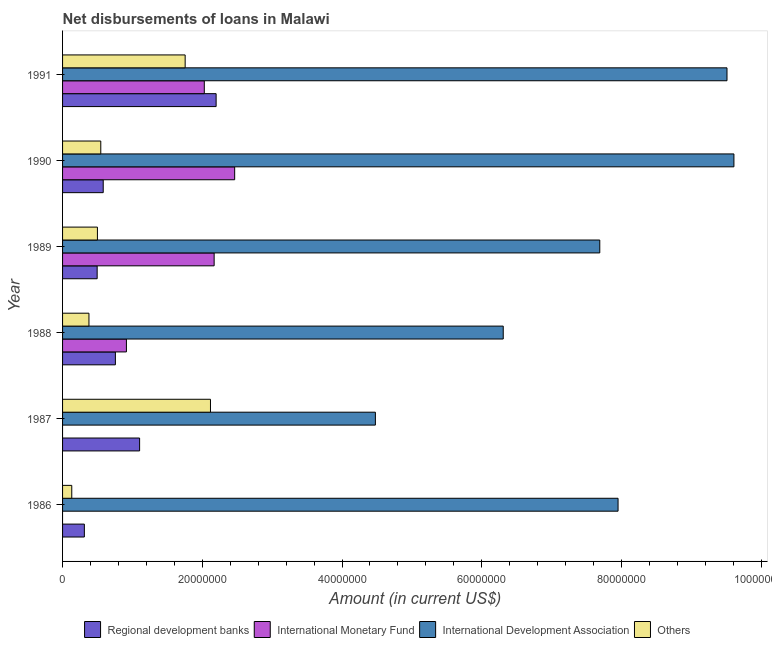How many groups of bars are there?
Ensure brevity in your answer.  6. How many bars are there on the 4th tick from the bottom?
Offer a very short reply. 4. What is the amount of loan disimbursed by other organisations in 1987?
Give a very brief answer. 2.12e+07. Across all years, what is the maximum amount of loan disimbursed by international monetary fund?
Your answer should be compact. 2.46e+07. Across all years, what is the minimum amount of loan disimbursed by regional development banks?
Provide a short and direct response. 3.12e+06. In which year was the amount of loan disimbursed by international monetary fund maximum?
Offer a very short reply. 1990. What is the total amount of loan disimbursed by international monetary fund in the graph?
Your answer should be very brief. 7.58e+07. What is the difference between the amount of loan disimbursed by international monetary fund in 1989 and that in 1991?
Offer a terse response. 1.41e+06. What is the difference between the amount of loan disimbursed by regional development banks in 1986 and the amount of loan disimbursed by international development association in 1989?
Your response must be concise. -7.38e+07. What is the average amount of loan disimbursed by international development association per year?
Give a very brief answer. 7.59e+07. In the year 1988, what is the difference between the amount of loan disimbursed by international development association and amount of loan disimbursed by international monetary fund?
Ensure brevity in your answer.  5.39e+07. What is the ratio of the amount of loan disimbursed by regional development banks in 1988 to that in 1990?
Keep it short and to the point. 1.3. Is the difference between the amount of loan disimbursed by other organisations in 1988 and 1991 greater than the difference between the amount of loan disimbursed by international monetary fund in 1988 and 1991?
Your answer should be compact. No. What is the difference between the highest and the second highest amount of loan disimbursed by regional development banks?
Ensure brevity in your answer.  1.10e+07. What is the difference between the highest and the lowest amount of loan disimbursed by other organisations?
Provide a short and direct response. 1.99e+07. In how many years, is the amount of loan disimbursed by regional development banks greater than the average amount of loan disimbursed by regional development banks taken over all years?
Ensure brevity in your answer.  2. Is the sum of the amount of loan disimbursed by other organisations in 1986 and 1991 greater than the maximum amount of loan disimbursed by international monetary fund across all years?
Offer a terse response. No. Is it the case that in every year, the sum of the amount of loan disimbursed by international development association and amount of loan disimbursed by regional development banks is greater than the sum of amount of loan disimbursed by international monetary fund and amount of loan disimbursed by other organisations?
Your answer should be very brief. Yes. Are all the bars in the graph horizontal?
Provide a succinct answer. Yes. What is the difference between two consecutive major ticks on the X-axis?
Provide a succinct answer. 2.00e+07. Are the values on the major ticks of X-axis written in scientific E-notation?
Keep it short and to the point. No. Does the graph contain grids?
Your response must be concise. No. How are the legend labels stacked?
Give a very brief answer. Horizontal. What is the title of the graph?
Keep it short and to the point. Net disbursements of loans in Malawi. What is the label or title of the X-axis?
Provide a short and direct response. Amount (in current US$). What is the Amount (in current US$) of Regional development banks in 1986?
Make the answer very short. 3.12e+06. What is the Amount (in current US$) of International Monetary Fund in 1986?
Your response must be concise. 0. What is the Amount (in current US$) in International Development Association in 1986?
Keep it short and to the point. 7.95e+07. What is the Amount (in current US$) of Others in 1986?
Your answer should be very brief. 1.32e+06. What is the Amount (in current US$) of Regional development banks in 1987?
Make the answer very short. 1.10e+07. What is the Amount (in current US$) in International Development Association in 1987?
Give a very brief answer. 4.48e+07. What is the Amount (in current US$) in Others in 1987?
Your answer should be very brief. 2.12e+07. What is the Amount (in current US$) in Regional development banks in 1988?
Keep it short and to the point. 7.56e+06. What is the Amount (in current US$) in International Monetary Fund in 1988?
Offer a very short reply. 9.14e+06. What is the Amount (in current US$) in International Development Association in 1988?
Your response must be concise. 6.31e+07. What is the Amount (in current US$) in Others in 1988?
Provide a succinct answer. 3.78e+06. What is the Amount (in current US$) in Regional development banks in 1989?
Give a very brief answer. 4.95e+06. What is the Amount (in current US$) of International Monetary Fund in 1989?
Keep it short and to the point. 2.17e+07. What is the Amount (in current US$) of International Development Association in 1989?
Provide a succinct answer. 7.69e+07. What is the Amount (in current US$) of Others in 1989?
Your response must be concise. 4.99e+06. What is the Amount (in current US$) of Regional development banks in 1990?
Provide a short and direct response. 5.82e+06. What is the Amount (in current US$) in International Monetary Fund in 1990?
Give a very brief answer. 2.46e+07. What is the Amount (in current US$) of International Development Association in 1990?
Your answer should be very brief. 9.61e+07. What is the Amount (in current US$) of Others in 1990?
Ensure brevity in your answer.  5.47e+06. What is the Amount (in current US$) in Regional development banks in 1991?
Provide a short and direct response. 2.20e+07. What is the Amount (in current US$) of International Monetary Fund in 1991?
Provide a succinct answer. 2.03e+07. What is the Amount (in current US$) in International Development Association in 1991?
Your answer should be compact. 9.51e+07. What is the Amount (in current US$) of Others in 1991?
Offer a very short reply. 1.75e+07. Across all years, what is the maximum Amount (in current US$) of Regional development banks?
Offer a very short reply. 2.20e+07. Across all years, what is the maximum Amount (in current US$) in International Monetary Fund?
Keep it short and to the point. 2.46e+07. Across all years, what is the maximum Amount (in current US$) of International Development Association?
Your answer should be compact. 9.61e+07. Across all years, what is the maximum Amount (in current US$) in Others?
Ensure brevity in your answer.  2.12e+07. Across all years, what is the minimum Amount (in current US$) of Regional development banks?
Your answer should be very brief. 3.12e+06. Across all years, what is the minimum Amount (in current US$) in International Monetary Fund?
Your response must be concise. 0. Across all years, what is the minimum Amount (in current US$) of International Development Association?
Your answer should be very brief. 4.48e+07. Across all years, what is the minimum Amount (in current US$) in Others?
Offer a very short reply. 1.32e+06. What is the total Amount (in current US$) of Regional development banks in the graph?
Ensure brevity in your answer.  5.45e+07. What is the total Amount (in current US$) of International Monetary Fund in the graph?
Ensure brevity in your answer.  7.58e+07. What is the total Amount (in current US$) in International Development Association in the graph?
Your answer should be compact. 4.55e+08. What is the total Amount (in current US$) in Others in the graph?
Your answer should be compact. 5.43e+07. What is the difference between the Amount (in current US$) of Regional development banks in 1986 and that in 1987?
Provide a short and direct response. -7.91e+06. What is the difference between the Amount (in current US$) in International Development Association in 1986 and that in 1987?
Offer a terse response. 3.47e+07. What is the difference between the Amount (in current US$) in Others in 1986 and that in 1987?
Make the answer very short. -1.99e+07. What is the difference between the Amount (in current US$) of Regional development banks in 1986 and that in 1988?
Provide a short and direct response. -4.44e+06. What is the difference between the Amount (in current US$) of International Development Association in 1986 and that in 1988?
Give a very brief answer. 1.64e+07. What is the difference between the Amount (in current US$) of Others in 1986 and that in 1988?
Offer a very short reply. -2.46e+06. What is the difference between the Amount (in current US$) of Regional development banks in 1986 and that in 1989?
Ensure brevity in your answer.  -1.83e+06. What is the difference between the Amount (in current US$) in International Development Association in 1986 and that in 1989?
Provide a succinct answer. 2.62e+06. What is the difference between the Amount (in current US$) of Others in 1986 and that in 1989?
Your answer should be compact. -3.67e+06. What is the difference between the Amount (in current US$) of Regional development banks in 1986 and that in 1990?
Provide a succinct answer. -2.70e+06. What is the difference between the Amount (in current US$) in International Development Association in 1986 and that in 1990?
Your answer should be compact. -1.66e+07. What is the difference between the Amount (in current US$) in Others in 1986 and that in 1990?
Your response must be concise. -4.15e+06. What is the difference between the Amount (in current US$) in Regional development banks in 1986 and that in 1991?
Give a very brief answer. -1.89e+07. What is the difference between the Amount (in current US$) in International Development Association in 1986 and that in 1991?
Make the answer very short. -1.56e+07. What is the difference between the Amount (in current US$) of Others in 1986 and that in 1991?
Offer a very short reply. -1.62e+07. What is the difference between the Amount (in current US$) in Regional development banks in 1987 and that in 1988?
Offer a very short reply. 3.47e+06. What is the difference between the Amount (in current US$) in International Development Association in 1987 and that in 1988?
Provide a short and direct response. -1.83e+07. What is the difference between the Amount (in current US$) of Others in 1987 and that in 1988?
Provide a succinct answer. 1.74e+07. What is the difference between the Amount (in current US$) of Regional development banks in 1987 and that in 1989?
Provide a short and direct response. 6.08e+06. What is the difference between the Amount (in current US$) in International Development Association in 1987 and that in 1989?
Give a very brief answer. -3.21e+07. What is the difference between the Amount (in current US$) in Others in 1987 and that in 1989?
Keep it short and to the point. 1.62e+07. What is the difference between the Amount (in current US$) of Regional development banks in 1987 and that in 1990?
Provide a succinct answer. 5.21e+06. What is the difference between the Amount (in current US$) in International Development Association in 1987 and that in 1990?
Make the answer very short. -5.13e+07. What is the difference between the Amount (in current US$) of Others in 1987 and that in 1990?
Offer a very short reply. 1.57e+07. What is the difference between the Amount (in current US$) of Regional development banks in 1987 and that in 1991?
Ensure brevity in your answer.  -1.10e+07. What is the difference between the Amount (in current US$) in International Development Association in 1987 and that in 1991?
Make the answer very short. -5.03e+07. What is the difference between the Amount (in current US$) of Others in 1987 and that in 1991?
Make the answer very short. 3.62e+06. What is the difference between the Amount (in current US$) of Regional development banks in 1988 and that in 1989?
Provide a succinct answer. 2.61e+06. What is the difference between the Amount (in current US$) of International Monetary Fund in 1988 and that in 1989?
Provide a succinct answer. -1.26e+07. What is the difference between the Amount (in current US$) of International Development Association in 1988 and that in 1989?
Make the answer very short. -1.38e+07. What is the difference between the Amount (in current US$) of Others in 1988 and that in 1989?
Offer a very short reply. -1.21e+06. What is the difference between the Amount (in current US$) of Regional development banks in 1988 and that in 1990?
Your response must be concise. 1.74e+06. What is the difference between the Amount (in current US$) in International Monetary Fund in 1988 and that in 1990?
Offer a very short reply. -1.55e+07. What is the difference between the Amount (in current US$) in International Development Association in 1988 and that in 1990?
Offer a very short reply. -3.30e+07. What is the difference between the Amount (in current US$) in Others in 1988 and that in 1990?
Ensure brevity in your answer.  -1.69e+06. What is the difference between the Amount (in current US$) of Regional development banks in 1988 and that in 1991?
Keep it short and to the point. -1.44e+07. What is the difference between the Amount (in current US$) of International Monetary Fund in 1988 and that in 1991?
Offer a terse response. -1.11e+07. What is the difference between the Amount (in current US$) of International Development Association in 1988 and that in 1991?
Offer a terse response. -3.20e+07. What is the difference between the Amount (in current US$) of Others in 1988 and that in 1991?
Provide a short and direct response. -1.38e+07. What is the difference between the Amount (in current US$) of Regional development banks in 1989 and that in 1990?
Provide a short and direct response. -8.68e+05. What is the difference between the Amount (in current US$) of International Monetary Fund in 1989 and that in 1990?
Keep it short and to the point. -2.94e+06. What is the difference between the Amount (in current US$) in International Development Association in 1989 and that in 1990?
Ensure brevity in your answer.  -1.92e+07. What is the difference between the Amount (in current US$) of Others in 1989 and that in 1990?
Your response must be concise. -4.80e+05. What is the difference between the Amount (in current US$) of Regional development banks in 1989 and that in 1991?
Provide a short and direct response. -1.70e+07. What is the difference between the Amount (in current US$) in International Monetary Fund in 1989 and that in 1991?
Make the answer very short. 1.41e+06. What is the difference between the Amount (in current US$) in International Development Association in 1989 and that in 1991?
Ensure brevity in your answer.  -1.82e+07. What is the difference between the Amount (in current US$) of Others in 1989 and that in 1991?
Offer a terse response. -1.26e+07. What is the difference between the Amount (in current US$) in Regional development banks in 1990 and that in 1991?
Make the answer very short. -1.62e+07. What is the difference between the Amount (in current US$) of International Monetary Fund in 1990 and that in 1991?
Your response must be concise. 4.35e+06. What is the difference between the Amount (in current US$) of International Development Association in 1990 and that in 1991?
Ensure brevity in your answer.  9.91e+05. What is the difference between the Amount (in current US$) of Others in 1990 and that in 1991?
Your answer should be compact. -1.21e+07. What is the difference between the Amount (in current US$) of Regional development banks in 1986 and the Amount (in current US$) of International Development Association in 1987?
Provide a short and direct response. -4.17e+07. What is the difference between the Amount (in current US$) of Regional development banks in 1986 and the Amount (in current US$) of Others in 1987?
Offer a terse response. -1.80e+07. What is the difference between the Amount (in current US$) of International Development Association in 1986 and the Amount (in current US$) of Others in 1987?
Your response must be concise. 5.83e+07. What is the difference between the Amount (in current US$) of Regional development banks in 1986 and the Amount (in current US$) of International Monetary Fund in 1988?
Ensure brevity in your answer.  -6.02e+06. What is the difference between the Amount (in current US$) of Regional development banks in 1986 and the Amount (in current US$) of International Development Association in 1988?
Keep it short and to the point. -6.00e+07. What is the difference between the Amount (in current US$) in Regional development banks in 1986 and the Amount (in current US$) in Others in 1988?
Provide a short and direct response. -6.57e+05. What is the difference between the Amount (in current US$) of International Development Association in 1986 and the Amount (in current US$) of Others in 1988?
Offer a terse response. 7.57e+07. What is the difference between the Amount (in current US$) of Regional development banks in 1986 and the Amount (in current US$) of International Monetary Fund in 1989?
Offer a very short reply. -1.86e+07. What is the difference between the Amount (in current US$) of Regional development banks in 1986 and the Amount (in current US$) of International Development Association in 1989?
Make the answer very short. -7.38e+07. What is the difference between the Amount (in current US$) in Regional development banks in 1986 and the Amount (in current US$) in Others in 1989?
Provide a short and direct response. -1.87e+06. What is the difference between the Amount (in current US$) of International Development Association in 1986 and the Amount (in current US$) of Others in 1989?
Your answer should be compact. 7.45e+07. What is the difference between the Amount (in current US$) in Regional development banks in 1986 and the Amount (in current US$) in International Monetary Fund in 1990?
Your answer should be compact. -2.15e+07. What is the difference between the Amount (in current US$) of Regional development banks in 1986 and the Amount (in current US$) of International Development Association in 1990?
Your response must be concise. -9.30e+07. What is the difference between the Amount (in current US$) in Regional development banks in 1986 and the Amount (in current US$) in Others in 1990?
Ensure brevity in your answer.  -2.35e+06. What is the difference between the Amount (in current US$) in International Development Association in 1986 and the Amount (in current US$) in Others in 1990?
Your answer should be compact. 7.40e+07. What is the difference between the Amount (in current US$) of Regional development banks in 1986 and the Amount (in current US$) of International Monetary Fund in 1991?
Give a very brief answer. -1.72e+07. What is the difference between the Amount (in current US$) of Regional development banks in 1986 and the Amount (in current US$) of International Development Association in 1991?
Offer a very short reply. -9.20e+07. What is the difference between the Amount (in current US$) in Regional development banks in 1986 and the Amount (in current US$) in Others in 1991?
Offer a terse response. -1.44e+07. What is the difference between the Amount (in current US$) of International Development Association in 1986 and the Amount (in current US$) of Others in 1991?
Offer a terse response. 6.20e+07. What is the difference between the Amount (in current US$) in Regional development banks in 1987 and the Amount (in current US$) in International Monetary Fund in 1988?
Your response must be concise. 1.89e+06. What is the difference between the Amount (in current US$) of Regional development banks in 1987 and the Amount (in current US$) of International Development Association in 1988?
Your answer should be very brief. -5.20e+07. What is the difference between the Amount (in current US$) in Regional development banks in 1987 and the Amount (in current US$) in Others in 1988?
Keep it short and to the point. 7.25e+06. What is the difference between the Amount (in current US$) of International Development Association in 1987 and the Amount (in current US$) of Others in 1988?
Your response must be concise. 4.10e+07. What is the difference between the Amount (in current US$) in Regional development banks in 1987 and the Amount (in current US$) in International Monetary Fund in 1989?
Your answer should be compact. -1.07e+07. What is the difference between the Amount (in current US$) in Regional development banks in 1987 and the Amount (in current US$) in International Development Association in 1989?
Your answer should be very brief. -6.59e+07. What is the difference between the Amount (in current US$) in Regional development banks in 1987 and the Amount (in current US$) in Others in 1989?
Give a very brief answer. 6.04e+06. What is the difference between the Amount (in current US$) of International Development Association in 1987 and the Amount (in current US$) of Others in 1989?
Make the answer very short. 3.98e+07. What is the difference between the Amount (in current US$) of Regional development banks in 1987 and the Amount (in current US$) of International Monetary Fund in 1990?
Offer a terse response. -1.36e+07. What is the difference between the Amount (in current US$) in Regional development banks in 1987 and the Amount (in current US$) in International Development Association in 1990?
Provide a short and direct response. -8.51e+07. What is the difference between the Amount (in current US$) of Regional development banks in 1987 and the Amount (in current US$) of Others in 1990?
Offer a terse response. 5.56e+06. What is the difference between the Amount (in current US$) in International Development Association in 1987 and the Amount (in current US$) in Others in 1990?
Your answer should be compact. 3.93e+07. What is the difference between the Amount (in current US$) in Regional development banks in 1987 and the Amount (in current US$) in International Monetary Fund in 1991?
Make the answer very short. -9.26e+06. What is the difference between the Amount (in current US$) of Regional development banks in 1987 and the Amount (in current US$) of International Development Association in 1991?
Your answer should be compact. -8.41e+07. What is the difference between the Amount (in current US$) of Regional development banks in 1987 and the Amount (in current US$) of Others in 1991?
Provide a succinct answer. -6.52e+06. What is the difference between the Amount (in current US$) of International Development Association in 1987 and the Amount (in current US$) of Others in 1991?
Provide a succinct answer. 2.72e+07. What is the difference between the Amount (in current US$) in Regional development banks in 1988 and the Amount (in current US$) in International Monetary Fund in 1989?
Your answer should be very brief. -1.41e+07. What is the difference between the Amount (in current US$) in Regional development banks in 1988 and the Amount (in current US$) in International Development Association in 1989?
Ensure brevity in your answer.  -6.93e+07. What is the difference between the Amount (in current US$) in Regional development banks in 1988 and the Amount (in current US$) in Others in 1989?
Make the answer very short. 2.57e+06. What is the difference between the Amount (in current US$) of International Monetary Fund in 1988 and the Amount (in current US$) of International Development Association in 1989?
Your answer should be very brief. -6.78e+07. What is the difference between the Amount (in current US$) of International Monetary Fund in 1988 and the Amount (in current US$) of Others in 1989?
Your answer should be very brief. 4.15e+06. What is the difference between the Amount (in current US$) in International Development Association in 1988 and the Amount (in current US$) in Others in 1989?
Ensure brevity in your answer.  5.81e+07. What is the difference between the Amount (in current US$) of Regional development banks in 1988 and the Amount (in current US$) of International Monetary Fund in 1990?
Ensure brevity in your answer.  -1.71e+07. What is the difference between the Amount (in current US$) of Regional development banks in 1988 and the Amount (in current US$) of International Development Association in 1990?
Give a very brief answer. -8.85e+07. What is the difference between the Amount (in current US$) in Regional development banks in 1988 and the Amount (in current US$) in Others in 1990?
Offer a terse response. 2.09e+06. What is the difference between the Amount (in current US$) of International Monetary Fund in 1988 and the Amount (in current US$) of International Development Association in 1990?
Your answer should be compact. -8.70e+07. What is the difference between the Amount (in current US$) in International Monetary Fund in 1988 and the Amount (in current US$) in Others in 1990?
Offer a very short reply. 3.67e+06. What is the difference between the Amount (in current US$) of International Development Association in 1988 and the Amount (in current US$) of Others in 1990?
Keep it short and to the point. 5.76e+07. What is the difference between the Amount (in current US$) of Regional development banks in 1988 and the Amount (in current US$) of International Monetary Fund in 1991?
Make the answer very short. -1.27e+07. What is the difference between the Amount (in current US$) of Regional development banks in 1988 and the Amount (in current US$) of International Development Association in 1991?
Keep it short and to the point. -8.75e+07. What is the difference between the Amount (in current US$) in Regional development banks in 1988 and the Amount (in current US$) in Others in 1991?
Make the answer very short. -9.99e+06. What is the difference between the Amount (in current US$) of International Monetary Fund in 1988 and the Amount (in current US$) of International Development Association in 1991?
Offer a terse response. -8.60e+07. What is the difference between the Amount (in current US$) of International Monetary Fund in 1988 and the Amount (in current US$) of Others in 1991?
Make the answer very short. -8.41e+06. What is the difference between the Amount (in current US$) in International Development Association in 1988 and the Amount (in current US$) in Others in 1991?
Give a very brief answer. 4.55e+07. What is the difference between the Amount (in current US$) in Regional development banks in 1989 and the Amount (in current US$) in International Monetary Fund in 1990?
Your response must be concise. -1.97e+07. What is the difference between the Amount (in current US$) of Regional development banks in 1989 and the Amount (in current US$) of International Development Association in 1990?
Give a very brief answer. -9.11e+07. What is the difference between the Amount (in current US$) in Regional development banks in 1989 and the Amount (in current US$) in Others in 1990?
Your answer should be very brief. -5.20e+05. What is the difference between the Amount (in current US$) in International Monetary Fund in 1989 and the Amount (in current US$) in International Development Association in 1990?
Offer a terse response. -7.44e+07. What is the difference between the Amount (in current US$) in International Monetary Fund in 1989 and the Amount (in current US$) in Others in 1990?
Provide a succinct answer. 1.62e+07. What is the difference between the Amount (in current US$) in International Development Association in 1989 and the Amount (in current US$) in Others in 1990?
Your response must be concise. 7.14e+07. What is the difference between the Amount (in current US$) of Regional development banks in 1989 and the Amount (in current US$) of International Monetary Fund in 1991?
Make the answer very short. -1.53e+07. What is the difference between the Amount (in current US$) in Regional development banks in 1989 and the Amount (in current US$) in International Development Association in 1991?
Offer a terse response. -9.02e+07. What is the difference between the Amount (in current US$) of Regional development banks in 1989 and the Amount (in current US$) of Others in 1991?
Provide a short and direct response. -1.26e+07. What is the difference between the Amount (in current US$) of International Monetary Fund in 1989 and the Amount (in current US$) of International Development Association in 1991?
Keep it short and to the point. -7.34e+07. What is the difference between the Amount (in current US$) of International Monetary Fund in 1989 and the Amount (in current US$) of Others in 1991?
Make the answer very short. 4.15e+06. What is the difference between the Amount (in current US$) of International Development Association in 1989 and the Amount (in current US$) of Others in 1991?
Your answer should be compact. 5.93e+07. What is the difference between the Amount (in current US$) of Regional development banks in 1990 and the Amount (in current US$) of International Monetary Fund in 1991?
Provide a succinct answer. -1.45e+07. What is the difference between the Amount (in current US$) of Regional development banks in 1990 and the Amount (in current US$) of International Development Association in 1991?
Offer a terse response. -8.93e+07. What is the difference between the Amount (in current US$) in Regional development banks in 1990 and the Amount (in current US$) in Others in 1991?
Ensure brevity in your answer.  -1.17e+07. What is the difference between the Amount (in current US$) in International Monetary Fund in 1990 and the Amount (in current US$) in International Development Association in 1991?
Provide a succinct answer. -7.05e+07. What is the difference between the Amount (in current US$) in International Monetary Fund in 1990 and the Amount (in current US$) in Others in 1991?
Your answer should be very brief. 7.09e+06. What is the difference between the Amount (in current US$) of International Development Association in 1990 and the Amount (in current US$) of Others in 1991?
Give a very brief answer. 7.85e+07. What is the average Amount (in current US$) in Regional development banks per year?
Offer a very short reply. 9.08e+06. What is the average Amount (in current US$) in International Monetary Fund per year?
Your answer should be very brief. 1.26e+07. What is the average Amount (in current US$) of International Development Association per year?
Your answer should be compact. 7.59e+07. What is the average Amount (in current US$) of Others per year?
Make the answer very short. 9.04e+06. In the year 1986, what is the difference between the Amount (in current US$) in Regional development banks and Amount (in current US$) in International Development Association?
Provide a succinct answer. -7.64e+07. In the year 1986, what is the difference between the Amount (in current US$) of Regional development banks and Amount (in current US$) of Others?
Your response must be concise. 1.80e+06. In the year 1986, what is the difference between the Amount (in current US$) of International Development Association and Amount (in current US$) of Others?
Provide a short and direct response. 7.82e+07. In the year 1987, what is the difference between the Amount (in current US$) of Regional development banks and Amount (in current US$) of International Development Association?
Your answer should be very brief. -3.37e+07. In the year 1987, what is the difference between the Amount (in current US$) in Regional development banks and Amount (in current US$) in Others?
Ensure brevity in your answer.  -1.01e+07. In the year 1987, what is the difference between the Amount (in current US$) of International Development Association and Amount (in current US$) of Others?
Ensure brevity in your answer.  2.36e+07. In the year 1988, what is the difference between the Amount (in current US$) of Regional development banks and Amount (in current US$) of International Monetary Fund?
Provide a short and direct response. -1.58e+06. In the year 1988, what is the difference between the Amount (in current US$) of Regional development banks and Amount (in current US$) of International Development Association?
Provide a succinct answer. -5.55e+07. In the year 1988, what is the difference between the Amount (in current US$) in Regional development banks and Amount (in current US$) in Others?
Your response must be concise. 3.78e+06. In the year 1988, what is the difference between the Amount (in current US$) in International Monetary Fund and Amount (in current US$) in International Development Association?
Keep it short and to the point. -5.39e+07. In the year 1988, what is the difference between the Amount (in current US$) in International Monetary Fund and Amount (in current US$) in Others?
Offer a terse response. 5.36e+06. In the year 1988, what is the difference between the Amount (in current US$) of International Development Association and Amount (in current US$) of Others?
Your answer should be compact. 5.93e+07. In the year 1989, what is the difference between the Amount (in current US$) in Regional development banks and Amount (in current US$) in International Monetary Fund?
Your response must be concise. -1.67e+07. In the year 1989, what is the difference between the Amount (in current US$) in Regional development banks and Amount (in current US$) in International Development Association?
Provide a short and direct response. -7.19e+07. In the year 1989, what is the difference between the Amount (in current US$) of International Monetary Fund and Amount (in current US$) of International Development Association?
Provide a succinct answer. -5.52e+07. In the year 1989, what is the difference between the Amount (in current US$) of International Monetary Fund and Amount (in current US$) of Others?
Give a very brief answer. 1.67e+07. In the year 1989, what is the difference between the Amount (in current US$) in International Development Association and Amount (in current US$) in Others?
Give a very brief answer. 7.19e+07. In the year 1990, what is the difference between the Amount (in current US$) of Regional development banks and Amount (in current US$) of International Monetary Fund?
Make the answer very short. -1.88e+07. In the year 1990, what is the difference between the Amount (in current US$) of Regional development banks and Amount (in current US$) of International Development Association?
Keep it short and to the point. -9.03e+07. In the year 1990, what is the difference between the Amount (in current US$) in Regional development banks and Amount (in current US$) in Others?
Your answer should be very brief. 3.48e+05. In the year 1990, what is the difference between the Amount (in current US$) of International Monetary Fund and Amount (in current US$) of International Development Association?
Keep it short and to the point. -7.15e+07. In the year 1990, what is the difference between the Amount (in current US$) in International Monetary Fund and Amount (in current US$) in Others?
Your answer should be compact. 1.92e+07. In the year 1990, what is the difference between the Amount (in current US$) of International Development Association and Amount (in current US$) of Others?
Provide a short and direct response. 9.06e+07. In the year 1991, what is the difference between the Amount (in current US$) of Regional development banks and Amount (in current US$) of International Monetary Fund?
Make the answer very short. 1.69e+06. In the year 1991, what is the difference between the Amount (in current US$) in Regional development banks and Amount (in current US$) in International Development Association?
Ensure brevity in your answer.  -7.31e+07. In the year 1991, what is the difference between the Amount (in current US$) of Regional development banks and Amount (in current US$) of Others?
Offer a very short reply. 4.43e+06. In the year 1991, what is the difference between the Amount (in current US$) in International Monetary Fund and Amount (in current US$) in International Development Association?
Your answer should be compact. -7.48e+07. In the year 1991, what is the difference between the Amount (in current US$) of International Monetary Fund and Amount (in current US$) of Others?
Give a very brief answer. 2.74e+06. In the year 1991, what is the difference between the Amount (in current US$) in International Development Association and Amount (in current US$) in Others?
Offer a terse response. 7.76e+07. What is the ratio of the Amount (in current US$) in Regional development banks in 1986 to that in 1987?
Keep it short and to the point. 0.28. What is the ratio of the Amount (in current US$) of International Development Association in 1986 to that in 1987?
Your answer should be very brief. 1.78. What is the ratio of the Amount (in current US$) of Others in 1986 to that in 1987?
Provide a short and direct response. 0.06. What is the ratio of the Amount (in current US$) in Regional development banks in 1986 to that in 1988?
Make the answer very short. 0.41. What is the ratio of the Amount (in current US$) in International Development Association in 1986 to that in 1988?
Offer a terse response. 1.26. What is the ratio of the Amount (in current US$) of Others in 1986 to that in 1988?
Ensure brevity in your answer.  0.35. What is the ratio of the Amount (in current US$) of Regional development banks in 1986 to that in 1989?
Provide a short and direct response. 0.63. What is the ratio of the Amount (in current US$) in International Development Association in 1986 to that in 1989?
Your answer should be compact. 1.03. What is the ratio of the Amount (in current US$) in Others in 1986 to that in 1989?
Ensure brevity in your answer.  0.26. What is the ratio of the Amount (in current US$) of Regional development banks in 1986 to that in 1990?
Offer a very short reply. 0.54. What is the ratio of the Amount (in current US$) in International Development Association in 1986 to that in 1990?
Your answer should be compact. 0.83. What is the ratio of the Amount (in current US$) in Others in 1986 to that in 1990?
Your response must be concise. 0.24. What is the ratio of the Amount (in current US$) of Regional development banks in 1986 to that in 1991?
Your response must be concise. 0.14. What is the ratio of the Amount (in current US$) in International Development Association in 1986 to that in 1991?
Your answer should be compact. 0.84. What is the ratio of the Amount (in current US$) in Others in 1986 to that in 1991?
Ensure brevity in your answer.  0.07. What is the ratio of the Amount (in current US$) of Regional development banks in 1987 to that in 1988?
Offer a very short reply. 1.46. What is the ratio of the Amount (in current US$) in International Development Association in 1987 to that in 1988?
Your response must be concise. 0.71. What is the ratio of the Amount (in current US$) of Others in 1987 to that in 1988?
Your response must be concise. 5.61. What is the ratio of the Amount (in current US$) of Regional development banks in 1987 to that in 1989?
Your response must be concise. 2.23. What is the ratio of the Amount (in current US$) in International Development Association in 1987 to that in 1989?
Your answer should be compact. 0.58. What is the ratio of the Amount (in current US$) in Others in 1987 to that in 1989?
Your answer should be compact. 4.24. What is the ratio of the Amount (in current US$) of Regional development banks in 1987 to that in 1990?
Give a very brief answer. 1.9. What is the ratio of the Amount (in current US$) in International Development Association in 1987 to that in 1990?
Your answer should be compact. 0.47. What is the ratio of the Amount (in current US$) in Others in 1987 to that in 1990?
Your response must be concise. 3.87. What is the ratio of the Amount (in current US$) of Regional development banks in 1987 to that in 1991?
Offer a very short reply. 0.5. What is the ratio of the Amount (in current US$) in International Development Association in 1987 to that in 1991?
Offer a terse response. 0.47. What is the ratio of the Amount (in current US$) in Others in 1987 to that in 1991?
Your answer should be compact. 1.21. What is the ratio of the Amount (in current US$) of Regional development banks in 1988 to that in 1989?
Your response must be concise. 1.53. What is the ratio of the Amount (in current US$) in International Monetary Fund in 1988 to that in 1989?
Offer a very short reply. 0.42. What is the ratio of the Amount (in current US$) of International Development Association in 1988 to that in 1989?
Ensure brevity in your answer.  0.82. What is the ratio of the Amount (in current US$) in Others in 1988 to that in 1989?
Give a very brief answer. 0.76. What is the ratio of the Amount (in current US$) in Regional development banks in 1988 to that in 1990?
Offer a very short reply. 1.3. What is the ratio of the Amount (in current US$) of International Monetary Fund in 1988 to that in 1990?
Ensure brevity in your answer.  0.37. What is the ratio of the Amount (in current US$) in International Development Association in 1988 to that in 1990?
Your answer should be compact. 0.66. What is the ratio of the Amount (in current US$) of Others in 1988 to that in 1990?
Your response must be concise. 0.69. What is the ratio of the Amount (in current US$) in Regional development banks in 1988 to that in 1991?
Your answer should be very brief. 0.34. What is the ratio of the Amount (in current US$) in International Monetary Fund in 1988 to that in 1991?
Provide a succinct answer. 0.45. What is the ratio of the Amount (in current US$) in International Development Association in 1988 to that in 1991?
Provide a short and direct response. 0.66. What is the ratio of the Amount (in current US$) in Others in 1988 to that in 1991?
Your response must be concise. 0.22. What is the ratio of the Amount (in current US$) of Regional development banks in 1989 to that in 1990?
Make the answer very short. 0.85. What is the ratio of the Amount (in current US$) in International Monetary Fund in 1989 to that in 1990?
Your answer should be very brief. 0.88. What is the ratio of the Amount (in current US$) in International Development Association in 1989 to that in 1990?
Your answer should be compact. 0.8. What is the ratio of the Amount (in current US$) in Others in 1989 to that in 1990?
Offer a terse response. 0.91. What is the ratio of the Amount (in current US$) in Regional development banks in 1989 to that in 1991?
Your answer should be very brief. 0.23. What is the ratio of the Amount (in current US$) of International Monetary Fund in 1989 to that in 1991?
Your answer should be very brief. 1.07. What is the ratio of the Amount (in current US$) in International Development Association in 1989 to that in 1991?
Give a very brief answer. 0.81. What is the ratio of the Amount (in current US$) of Others in 1989 to that in 1991?
Your response must be concise. 0.28. What is the ratio of the Amount (in current US$) of Regional development banks in 1990 to that in 1991?
Ensure brevity in your answer.  0.26. What is the ratio of the Amount (in current US$) of International Monetary Fund in 1990 to that in 1991?
Offer a very short reply. 1.21. What is the ratio of the Amount (in current US$) of International Development Association in 1990 to that in 1991?
Keep it short and to the point. 1.01. What is the ratio of the Amount (in current US$) in Others in 1990 to that in 1991?
Ensure brevity in your answer.  0.31. What is the difference between the highest and the second highest Amount (in current US$) in Regional development banks?
Provide a succinct answer. 1.10e+07. What is the difference between the highest and the second highest Amount (in current US$) of International Monetary Fund?
Give a very brief answer. 2.94e+06. What is the difference between the highest and the second highest Amount (in current US$) of International Development Association?
Provide a succinct answer. 9.91e+05. What is the difference between the highest and the second highest Amount (in current US$) of Others?
Provide a succinct answer. 3.62e+06. What is the difference between the highest and the lowest Amount (in current US$) of Regional development banks?
Offer a terse response. 1.89e+07. What is the difference between the highest and the lowest Amount (in current US$) of International Monetary Fund?
Provide a short and direct response. 2.46e+07. What is the difference between the highest and the lowest Amount (in current US$) in International Development Association?
Your response must be concise. 5.13e+07. What is the difference between the highest and the lowest Amount (in current US$) in Others?
Provide a succinct answer. 1.99e+07. 